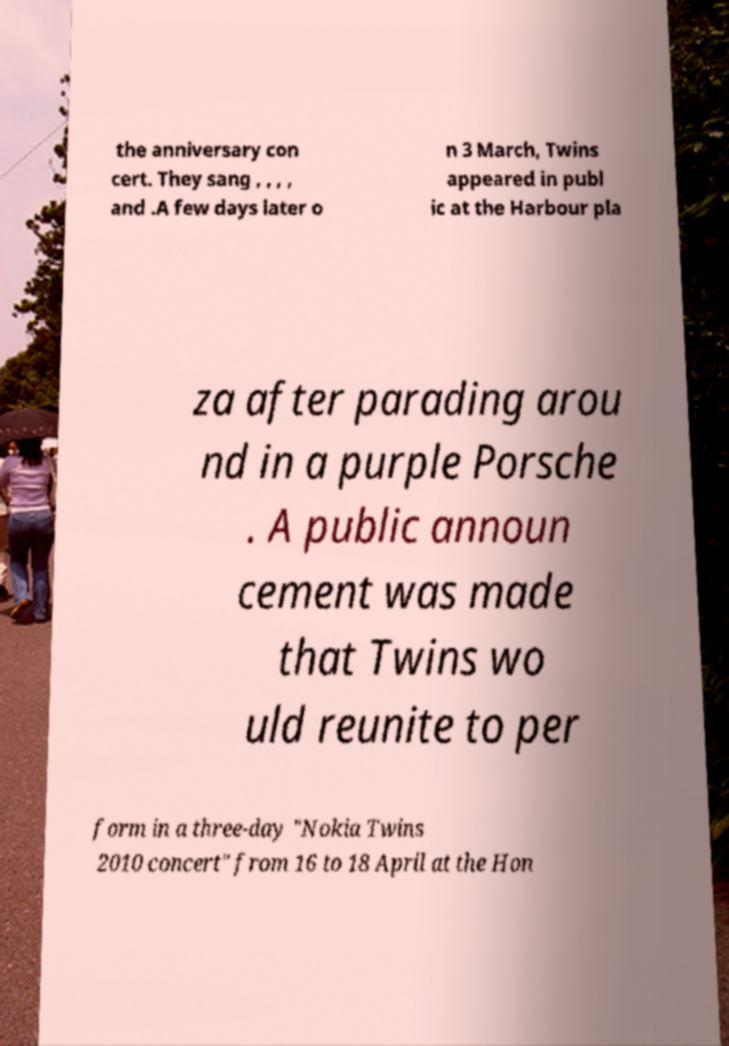Please read and relay the text visible in this image. What does it say? the anniversary con cert. They sang , , , , and .A few days later o n 3 March, Twins appeared in publ ic at the Harbour pla za after parading arou nd in a purple Porsche . A public announ cement was made that Twins wo uld reunite to per form in a three-day "Nokia Twins 2010 concert" from 16 to 18 April at the Hon 